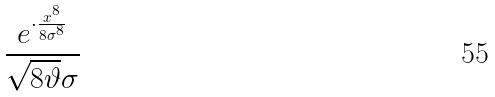Convert formula to latex. <formula><loc_0><loc_0><loc_500><loc_500>\frac { e ^ { \cdot \frac { x ^ { 8 } } { 8 \sigma ^ { 8 } } } } { \sqrt { 8 \vartheta } \sigma }</formula> 